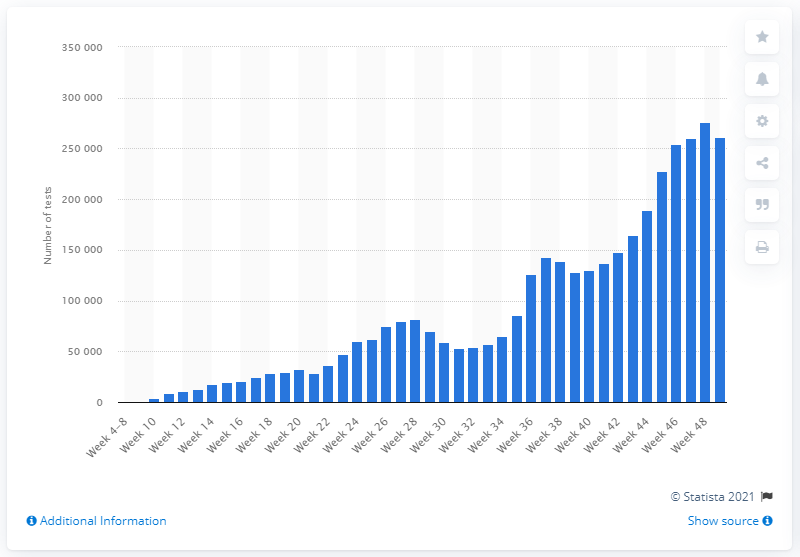Give some essential details in this illustration. In the fourth week of December 2020, a total of 261,229 people were tested for the coronavirus. 